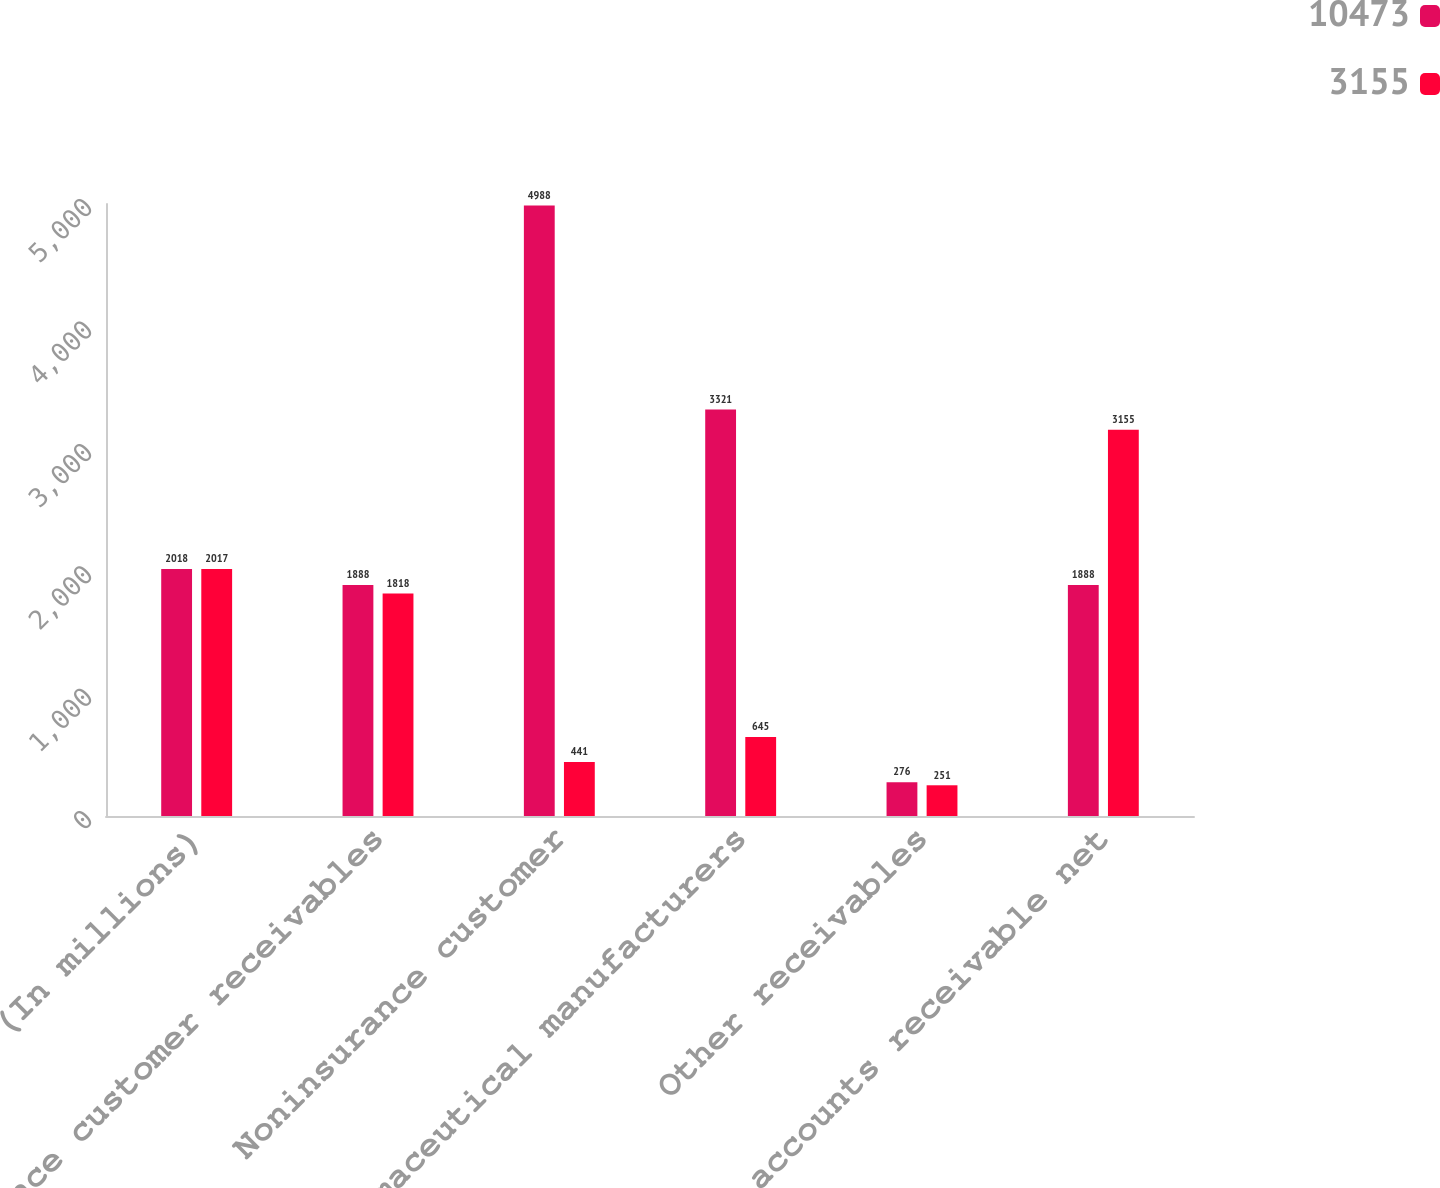Convert chart to OTSL. <chart><loc_0><loc_0><loc_500><loc_500><stacked_bar_chart><ecel><fcel>(In millions)<fcel>Insurance customer receivables<fcel>Noninsurance customer<fcel>Pharmaceutical manufacturers<fcel>Other receivables<fcel>Total accounts receivable net<nl><fcel>10473<fcel>2018<fcel>1888<fcel>4988<fcel>3321<fcel>276<fcel>1888<nl><fcel>3155<fcel>2017<fcel>1818<fcel>441<fcel>645<fcel>251<fcel>3155<nl></chart> 